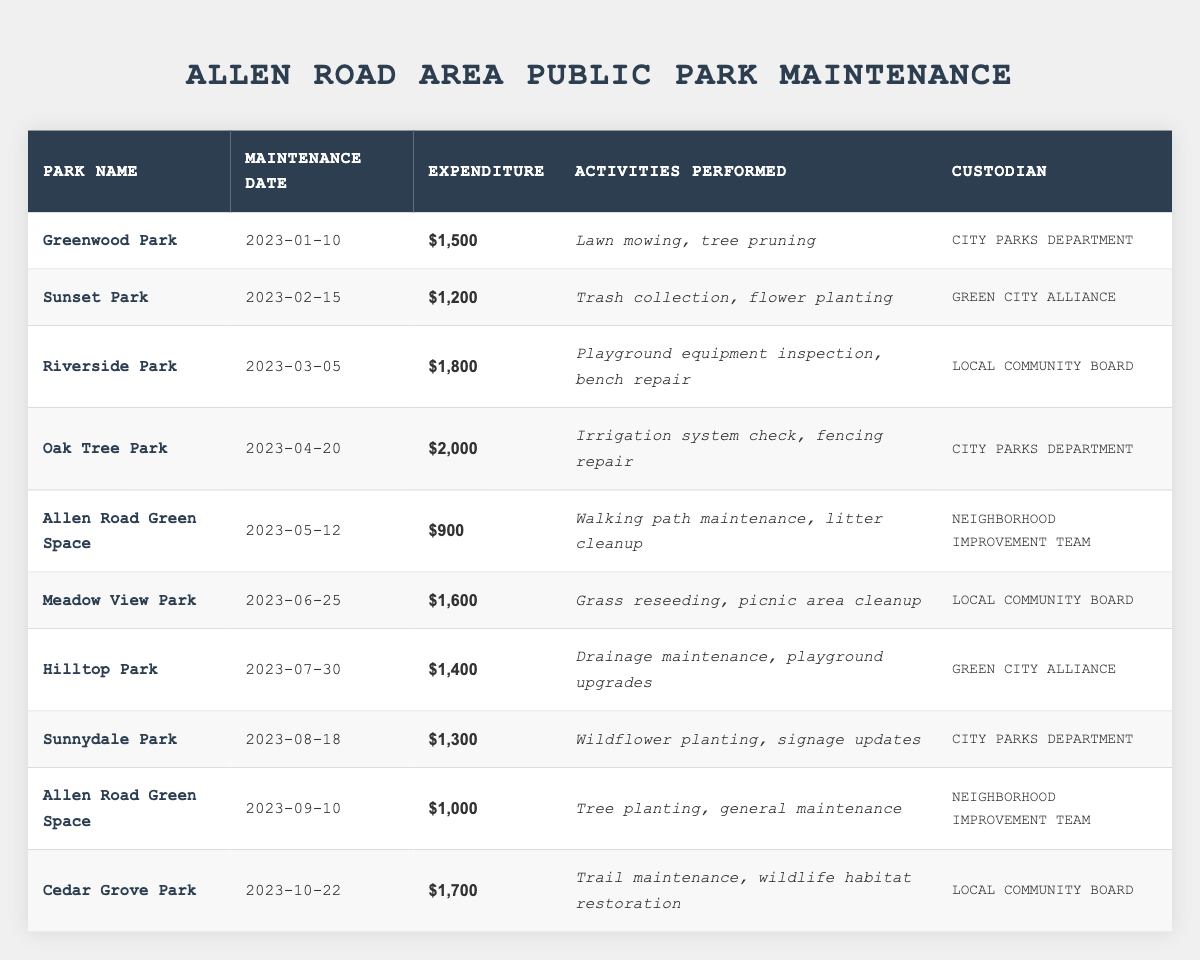What is the total expenditure for maintenance at Allen Road Green Space? The expenditure for Allen Road Green Space maintenance has two entries: $900 on 2023-05-12 and $1,000 on 2023-09-10. Adding these together gives $900 + $1,000 = $1,900.
Answer: $1,900 Which park had the highest maintenance expenditure and what was the amount? Looking through the table, Oak Tree Park has the highest expenditure of $2,000 on 2023-04-20.
Answer: Oak Tree Park, $2,000 How many times was Allen Road Green Space maintained in 2023? The table shows that Allen Road Green Space was maintained twice: once on 2023-05-12 and again on 2023-09-10.
Answer: 2 times What is the average expenditure for all parks listed in the table? To find the average, we sum all the expenditures: $1,500 + $1,200 + $1,800 + $2,000 + $900 + $1,600 + $1,400 + $1,300 + $1,000 + $1,700 = $14,100. There are 10 parks, so we divide: $14,100 / 10 = $1,410.
Answer: $1,410 Did any park have maintenance activities that included tree planting? Yes, Allen Road Green Space had tree planting as one of its maintenance activities on 2023-09-10.
Answer: Yes Which custodian was responsible for the maintenance of the most parks? The custodians are City Parks Department (3 parks: Greenwood Park, Oak Tree Park, Sunnydale Park), Local Community Board (3 parks: Riverside Park, Meadow View Park, Cedar Grove Park), and Neighborhood Improvement Team (2 parks: Allen Road Green Space). City Parks Department and Local Community Board each managed 3 parks, which is the highest count.
Answer: City Parks Department and Local Community Board (3 each) What maintenance activity was performed at Riverside Park? According to the table, the activities performed at Riverside Park included playground equipment inspection and bench repair on 2023-03-05.
Answer: Playground equipment inspection, bench repair What is the difference between the highest and lowest expenditures for park maintenance? The highest expenditure is $2,000 for Oak Tree Park and the lowest is $900 for Allen Road Green Space. The difference is $2,000 - $900 = $1,100.
Answer: $1,100 How many parks were maintained in the month of August? Checking the table, there is only one park, Sunnydale Park, that was maintained in August, on 2023-08-18.
Answer: 1 park Did the Allen Road Green Space have more expenditure during its first maintenance than its second? Comparing the two maintainence expenditures, $900 on 2023-05-12 (first) and $1,000 on 2023-09-10 (second), the second maintenance had a higher expense.
Answer: No 